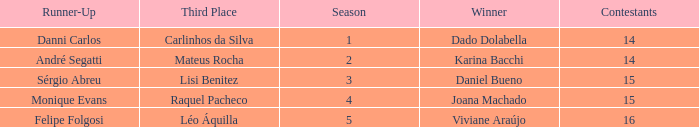Would you mind parsing the complete table? {'header': ['Runner-Up', 'Third Place', 'Season', 'Winner', 'Contestants'], 'rows': [['Danni Carlos', 'Carlinhos da Silva', '1', 'Dado Dolabella', '14'], ['André Segatti', 'Mateus Rocha', '2', 'Karina Bacchi', '14'], ['Sérgio Abreu', 'Lisi Benitez', '3', 'Daniel Bueno', '15'], ['Monique Evans', 'Raquel Pacheco', '4', 'Joana Machado', '15'], ['Felipe Folgosi', 'Léo Áquilla', '5', 'Viviane Araújo', '16']]} In what season was the winner Dado Dolabella? 1.0. 